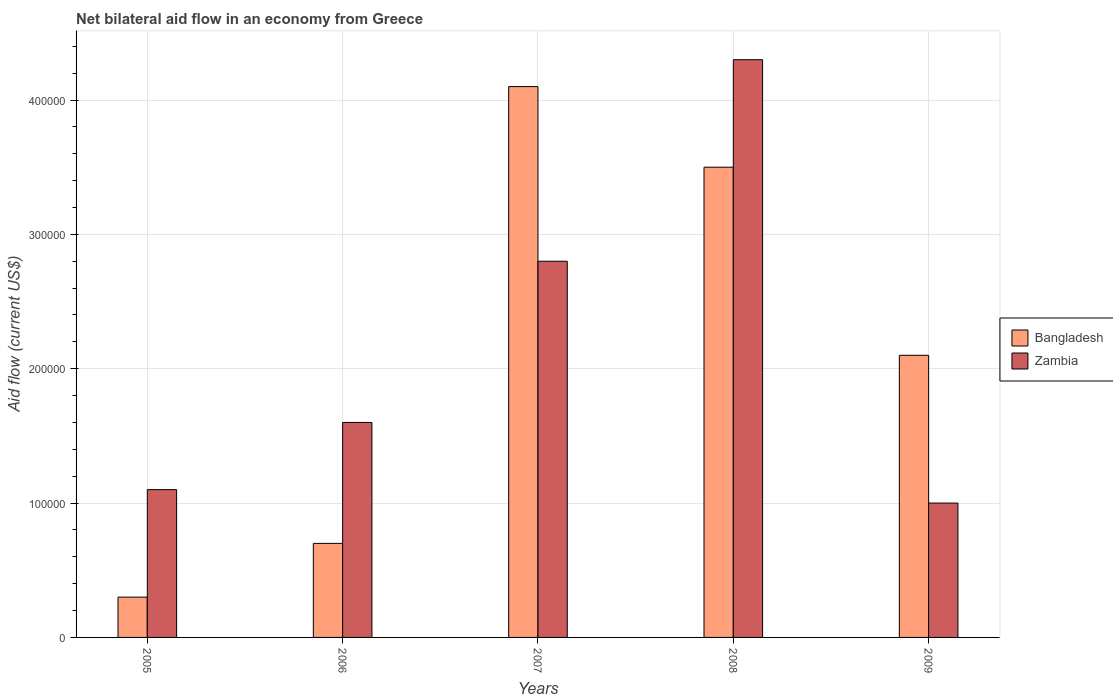How many different coloured bars are there?
Your response must be concise. 2. Are the number of bars per tick equal to the number of legend labels?
Provide a succinct answer. Yes. How many bars are there on the 5th tick from the left?
Provide a short and direct response. 2. How many bars are there on the 5th tick from the right?
Provide a succinct answer. 2. In how many cases, is the number of bars for a given year not equal to the number of legend labels?
Your answer should be very brief. 0. What is the net bilateral aid flow in Zambia in 2006?
Your answer should be compact. 1.60e+05. In which year was the net bilateral aid flow in Bangladesh maximum?
Provide a succinct answer. 2007. What is the total net bilateral aid flow in Bangladesh in the graph?
Your response must be concise. 1.07e+06. What is the difference between the net bilateral aid flow in Bangladesh in 2005 and that in 2006?
Your response must be concise. -4.00e+04. What is the difference between the net bilateral aid flow in Bangladesh in 2008 and the net bilateral aid flow in Zambia in 2009?
Your answer should be very brief. 2.50e+05. What is the average net bilateral aid flow in Zambia per year?
Ensure brevity in your answer.  2.16e+05. In how many years, is the net bilateral aid flow in Bangladesh greater than 60000 US$?
Keep it short and to the point. 4. What is the ratio of the net bilateral aid flow in Bangladesh in 2006 to that in 2007?
Make the answer very short. 0.17. Is the net bilateral aid flow in Zambia in 2006 less than that in 2009?
Your answer should be compact. No. Is the difference between the net bilateral aid flow in Zambia in 2005 and 2006 greater than the difference between the net bilateral aid flow in Bangladesh in 2005 and 2006?
Give a very brief answer. No. What is the difference between the highest and the second highest net bilateral aid flow in Zambia?
Ensure brevity in your answer.  1.50e+05. What is the difference between the highest and the lowest net bilateral aid flow in Bangladesh?
Offer a very short reply. 3.80e+05. In how many years, is the net bilateral aid flow in Zambia greater than the average net bilateral aid flow in Zambia taken over all years?
Make the answer very short. 2. Is the sum of the net bilateral aid flow in Bangladesh in 2005 and 2007 greater than the maximum net bilateral aid flow in Zambia across all years?
Your answer should be compact. Yes. What does the 1st bar from the left in 2005 represents?
Offer a terse response. Bangladesh. What does the 2nd bar from the right in 2005 represents?
Your answer should be compact. Bangladesh. How many bars are there?
Keep it short and to the point. 10. How many years are there in the graph?
Provide a succinct answer. 5. What is the difference between two consecutive major ticks on the Y-axis?
Your response must be concise. 1.00e+05. Does the graph contain grids?
Provide a short and direct response. Yes. How many legend labels are there?
Offer a very short reply. 2. How are the legend labels stacked?
Provide a succinct answer. Vertical. What is the title of the graph?
Provide a short and direct response. Net bilateral aid flow in an economy from Greece. Does "Central Europe" appear as one of the legend labels in the graph?
Your answer should be compact. No. What is the label or title of the X-axis?
Make the answer very short. Years. What is the Aid flow (current US$) in Bangladesh in 2005?
Make the answer very short. 3.00e+04. What is the Aid flow (current US$) in Zambia in 2005?
Ensure brevity in your answer.  1.10e+05. What is the Aid flow (current US$) of Bangladesh in 2006?
Give a very brief answer. 7.00e+04. What is the Aid flow (current US$) of Zambia in 2006?
Provide a short and direct response. 1.60e+05. What is the Aid flow (current US$) of Zambia in 2007?
Provide a succinct answer. 2.80e+05. What is the Aid flow (current US$) in Zambia in 2008?
Your answer should be compact. 4.30e+05. What is the Aid flow (current US$) in Zambia in 2009?
Offer a terse response. 1.00e+05. Across all years, what is the maximum Aid flow (current US$) in Bangladesh?
Provide a succinct answer. 4.10e+05. Across all years, what is the maximum Aid flow (current US$) in Zambia?
Offer a very short reply. 4.30e+05. Across all years, what is the minimum Aid flow (current US$) of Zambia?
Provide a succinct answer. 1.00e+05. What is the total Aid flow (current US$) of Bangladesh in the graph?
Ensure brevity in your answer.  1.07e+06. What is the total Aid flow (current US$) in Zambia in the graph?
Make the answer very short. 1.08e+06. What is the difference between the Aid flow (current US$) of Bangladesh in 2005 and that in 2006?
Make the answer very short. -4.00e+04. What is the difference between the Aid flow (current US$) of Zambia in 2005 and that in 2006?
Make the answer very short. -5.00e+04. What is the difference between the Aid flow (current US$) in Bangladesh in 2005 and that in 2007?
Provide a succinct answer. -3.80e+05. What is the difference between the Aid flow (current US$) in Bangladesh in 2005 and that in 2008?
Provide a short and direct response. -3.20e+05. What is the difference between the Aid flow (current US$) of Zambia in 2005 and that in 2008?
Provide a succinct answer. -3.20e+05. What is the difference between the Aid flow (current US$) of Bangladesh in 2005 and that in 2009?
Offer a very short reply. -1.80e+05. What is the difference between the Aid flow (current US$) of Bangladesh in 2006 and that in 2007?
Give a very brief answer. -3.40e+05. What is the difference between the Aid flow (current US$) of Bangladesh in 2006 and that in 2008?
Offer a terse response. -2.80e+05. What is the difference between the Aid flow (current US$) in Bangladesh in 2006 and that in 2009?
Your response must be concise. -1.40e+05. What is the difference between the Aid flow (current US$) in Zambia in 2007 and that in 2009?
Keep it short and to the point. 1.80e+05. What is the difference between the Aid flow (current US$) in Bangladesh in 2008 and that in 2009?
Give a very brief answer. 1.40e+05. What is the difference between the Aid flow (current US$) of Zambia in 2008 and that in 2009?
Provide a short and direct response. 3.30e+05. What is the difference between the Aid flow (current US$) of Bangladesh in 2005 and the Aid flow (current US$) of Zambia in 2008?
Offer a very short reply. -4.00e+05. What is the difference between the Aid flow (current US$) of Bangladesh in 2005 and the Aid flow (current US$) of Zambia in 2009?
Ensure brevity in your answer.  -7.00e+04. What is the difference between the Aid flow (current US$) of Bangladesh in 2006 and the Aid flow (current US$) of Zambia in 2008?
Your answer should be compact. -3.60e+05. What is the average Aid flow (current US$) in Bangladesh per year?
Provide a short and direct response. 2.14e+05. What is the average Aid flow (current US$) of Zambia per year?
Ensure brevity in your answer.  2.16e+05. In the year 2005, what is the difference between the Aid flow (current US$) of Bangladesh and Aid flow (current US$) of Zambia?
Your answer should be very brief. -8.00e+04. In the year 2008, what is the difference between the Aid flow (current US$) in Bangladesh and Aid flow (current US$) in Zambia?
Keep it short and to the point. -8.00e+04. In the year 2009, what is the difference between the Aid flow (current US$) of Bangladesh and Aid flow (current US$) of Zambia?
Make the answer very short. 1.10e+05. What is the ratio of the Aid flow (current US$) in Bangladesh in 2005 to that in 2006?
Keep it short and to the point. 0.43. What is the ratio of the Aid flow (current US$) of Zambia in 2005 to that in 2006?
Give a very brief answer. 0.69. What is the ratio of the Aid flow (current US$) in Bangladesh in 2005 to that in 2007?
Offer a terse response. 0.07. What is the ratio of the Aid flow (current US$) of Zambia in 2005 to that in 2007?
Offer a terse response. 0.39. What is the ratio of the Aid flow (current US$) in Bangladesh in 2005 to that in 2008?
Your response must be concise. 0.09. What is the ratio of the Aid flow (current US$) of Zambia in 2005 to that in 2008?
Make the answer very short. 0.26. What is the ratio of the Aid flow (current US$) in Bangladesh in 2005 to that in 2009?
Ensure brevity in your answer.  0.14. What is the ratio of the Aid flow (current US$) in Zambia in 2005 to that in 2009?
Offer a very short reply. 1.1. What is the ratio of the Aid flow (current US$) of Bangladesh in 2006 to that in 2007?
Your answer should be very brief. 0.17. What is the ratio of the Aid flow (current US$) of Zambia in 2006 to that in 2007?
Keep it short and to the point. 0.57. What is the ratio of the Aid flow (current US$) of Bangladesh in 2006 to that in 2008?
Your answer should be compact. 0.2. What is the ratio of the Aid flow (current US$) of Zambia in 2006 to that in 2008?
Make the answer very short. 0.37. What is the ratio of the Aid flow (current US$) in Zambia in 2006 to that in 2009?
Give a very brief answer. 1.6. What is the ratio of the Aid flow (current US$) of Bangladesh in 2007 to that in 2008?
Your answer should be compact. 1.17. What is the ratio of the Aid flow (current US$) of Zambia in 2007 to that in 2008?
Provide a short and direct response. 0.65. What is the ratio of the Aid flow (current US$) in Bangladesh in 2007 to that in 2009?
Your response must be concise. 1.95. What is the ratio of the Aid flow (current US$) of Zambia in 2007 to that in 2009?
Provide a short and direct response. 2.8. What is the ratio of the Aid flow (current US$) of Bangladesh in 2008 to that in 2009?
Provide a short and direct response. 1.67. What is the ratio of the Aid flow (current US$) of Zambia in 2008 to that in 2009?
Keep it short and to the point. 4.3. What is the difference between the highest and the second highest Aid flow (current US$) in Zambia?
Your answer should be very brief. 1.50e+05. What is the difference between the highest and the lowest Aid flow (current US$) in Bangladesh?
Your response must be concise. 3.80e+05. What is the difference between the highest and the lowest Aid flow (current US$) of Zambia?
Ensure brevity in your answer.  3.30e+05. 